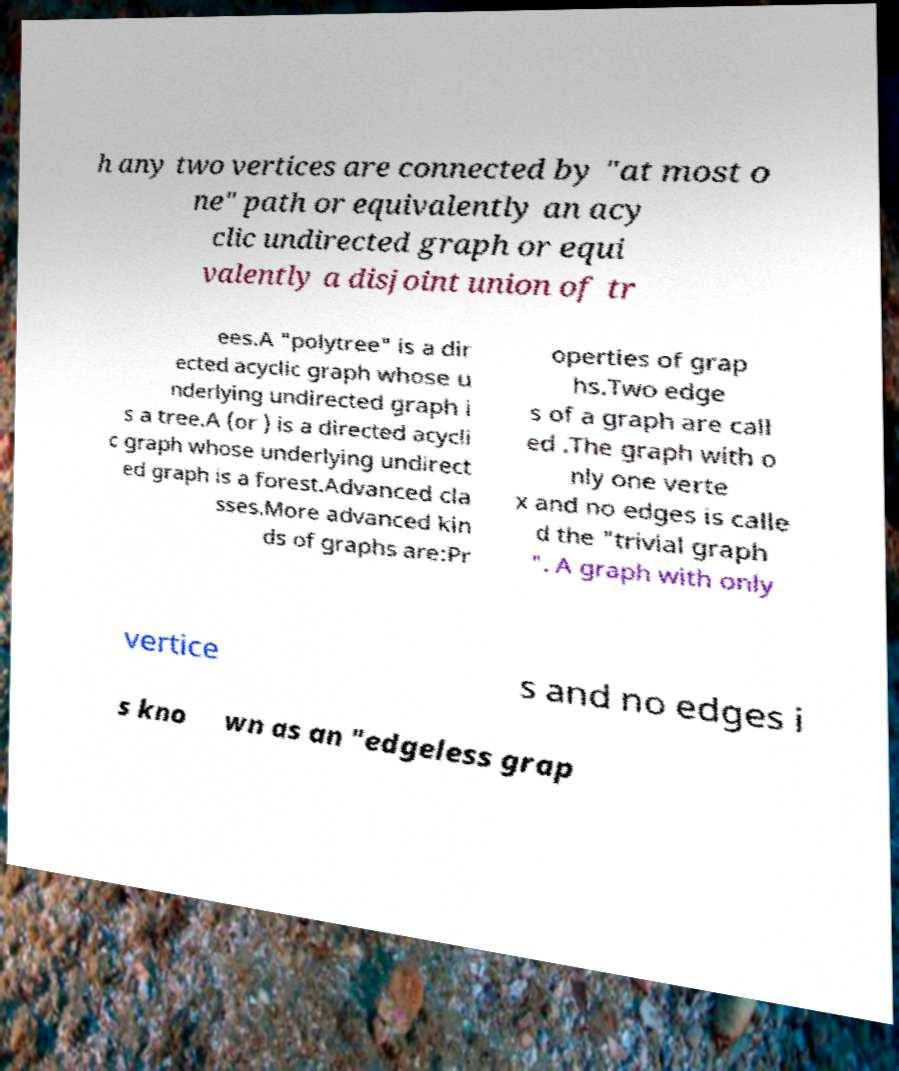Please identify and transcribe the text found in this image. h any two vertices are connected by "at most o ne" path or equivalently an acy clic undirected graph or equi valently a disjoint union of tr ees.A "polytree" is a dir ected acyclic graph whose u nderlying undirected graph i s a tree.A (or ) is a directed acycli c graph whose underlying undirect ed graph is a forest.Advanced cla sses.More advanced kin ds of graphs are:Pr operties of grap hs.Two edge s of a graph are call ed .The graph with o nly one verte x and no edges is calle d the "trivial graph ". A graph with only vertice s and no edges i s kno wn as an "edgeless grap 